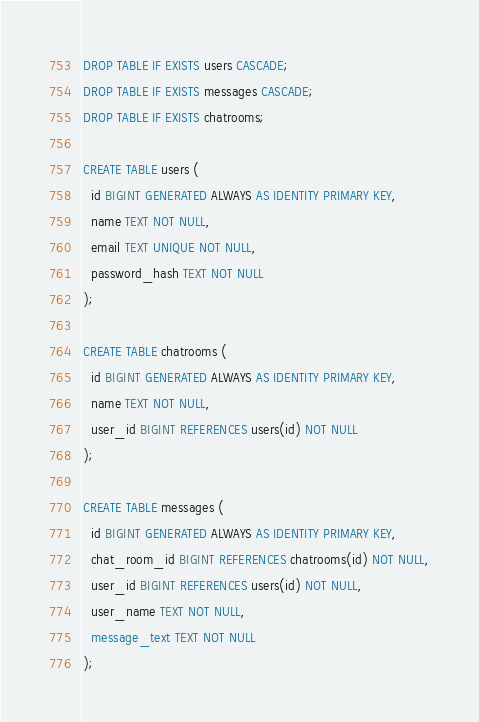Convert code to text. <code><loc_0><loc_0><loc_500><loc_500><_SQL_>DROP TABLE IF EXISTS users CASCADE;
DROP TABLE IF EXISTS messages CASCADE;
DROP TABLE IF EXISTS chatrooms;

CREATE TABLE users (
  id BIGINT GENERATED ALWAYS AS IDENTITY PRIMARY KEY,
  name TEXT NOT NULL,
  email TEXT UNIQUE NOT NULL,
  password_hash TEXT NOT NULL
);

CREATE TABLE chatrooms (
  id BIGINT GENERATED ALWAYS AS IDENTITY PRIMARY KEY,
  name TEXT NOT NULL,
  user_id BIGINT REFERENCES users(id) NOT NULL
);

CREATE TABLE messages (
  id BIGINT GENERATED ALWAYS AS IDENTITY PRIMARY KEY,
  chat_room_id BIGINT REFERENCES chatrooms(id) NOT NULL,
  user_id BIGINT REFERENCES users(id) NOT NULL,
  user_name TEXT NOT NULL,
  message_text TEXT NOT NULL
);

</code> 